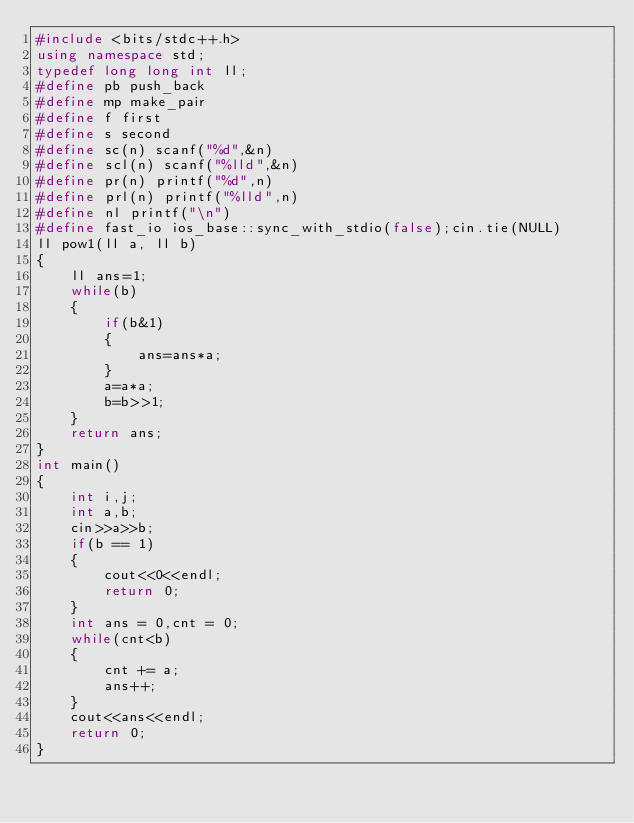Convert code to text. <code><loc_0><loc_0><loc_500><loc_500><_C++_>#include <bits/stdc++.h>
using namespace std;
typedef long long int ll;
#define pb push_back
#define mp make_pair
#define f first
#define s second
#define sc(n) scanf("%d",&n)
#define scl(n) scanf("%lld",&n)
#define pr(n) printf("%d",n)
#define prl(n) printf("%lld",n)
#define nl printf("\n")
#define fast_io ios_base::sync_with_stdio(false);cin.tie(NULL)
ll pow1(ll a, ll b)
{
	ll ans=1;
	while(b)
	{
		if(b&1)
		{
			ans=ans*a;
		}
		a=a*a;
		b=b>>1;
	}
	return ans;
}
int main()
{
	int i,j;
	int a,b;
	cin>>a>>b;
	if(b == 1)
	{
		cout<<0<<endl;
		return 0;
	}
	int ans = 0,cnt = 0;
	while(cnt<b)
	{
		cnt += a;
		ans++;
	}
	cout<<ans<<endl;
	return 0;
}</code> 